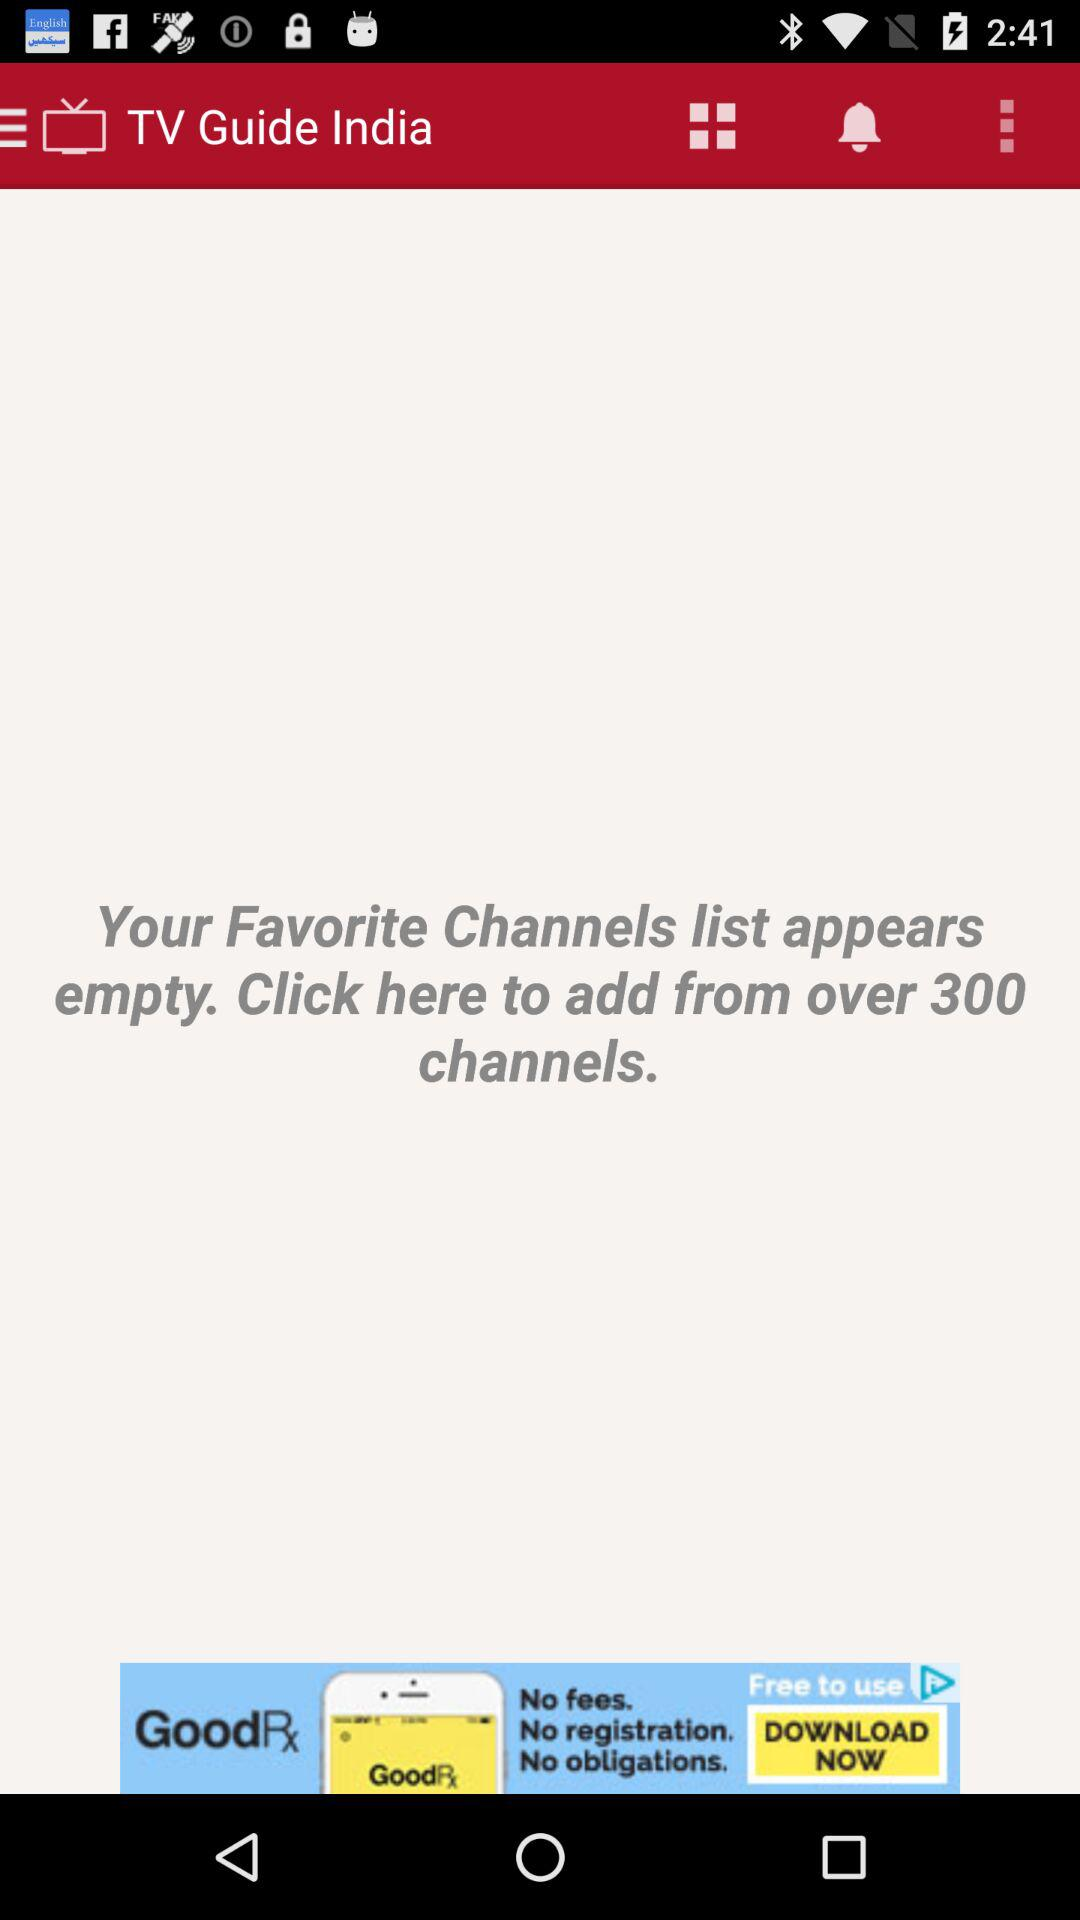What is the app name? The app name is "TV Guide India". 